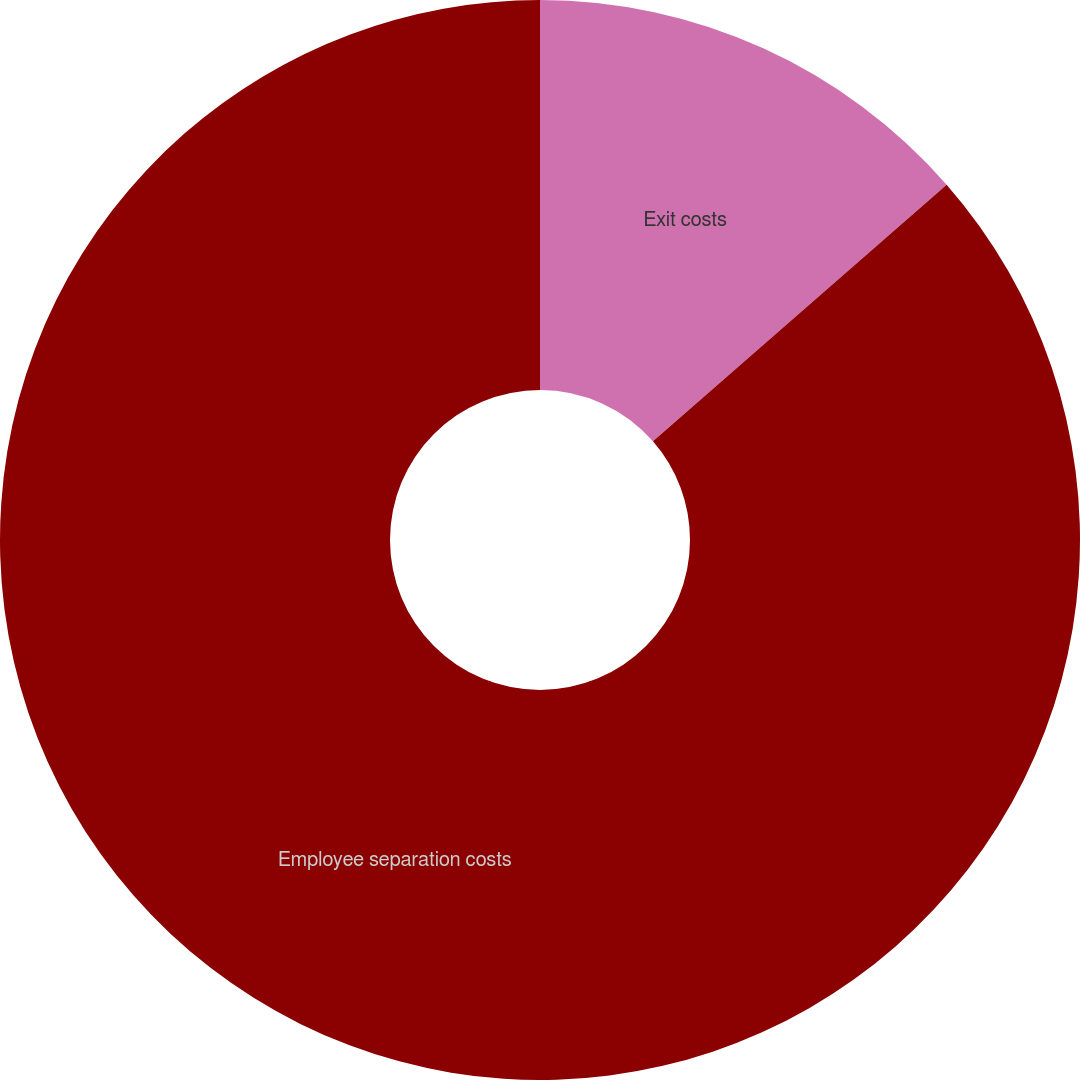<chart> <loc_0><loc_0><loc_500><loc_500><pie_chart><fcel>Exit costs<fcel>Employee separation costs<nl><fcel>13.57%<fcel>86.43%<nl></chart> 